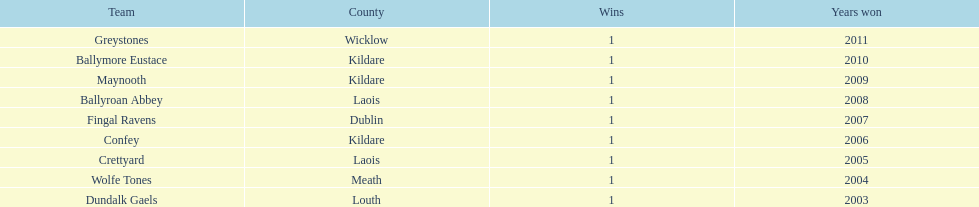What is the total count of wins for every team? 1. 